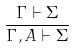Convert formula to latex. <formula><loc_0><loc_0><loc_500><loc_500>\frac { \Gamma \vdash \Sigma } { \Gamma , A \vdash \Sigma }</formula> 